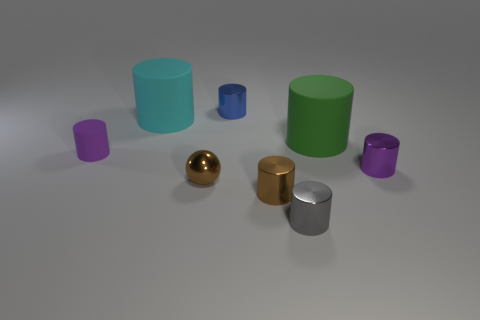How many objects are there in total in the image, and can you describe their colors and textures? There are a total of seven objects in the image. Starting from the left, there's a small purple matte cylinder, a medium-sized cyan matte cylinder, a large green matte cylinder, a tiny brown metal cylinder with a reflective surface, a gold shiny sphere, a medium brown shiny cylinder, and a small purple matte cylinder. 